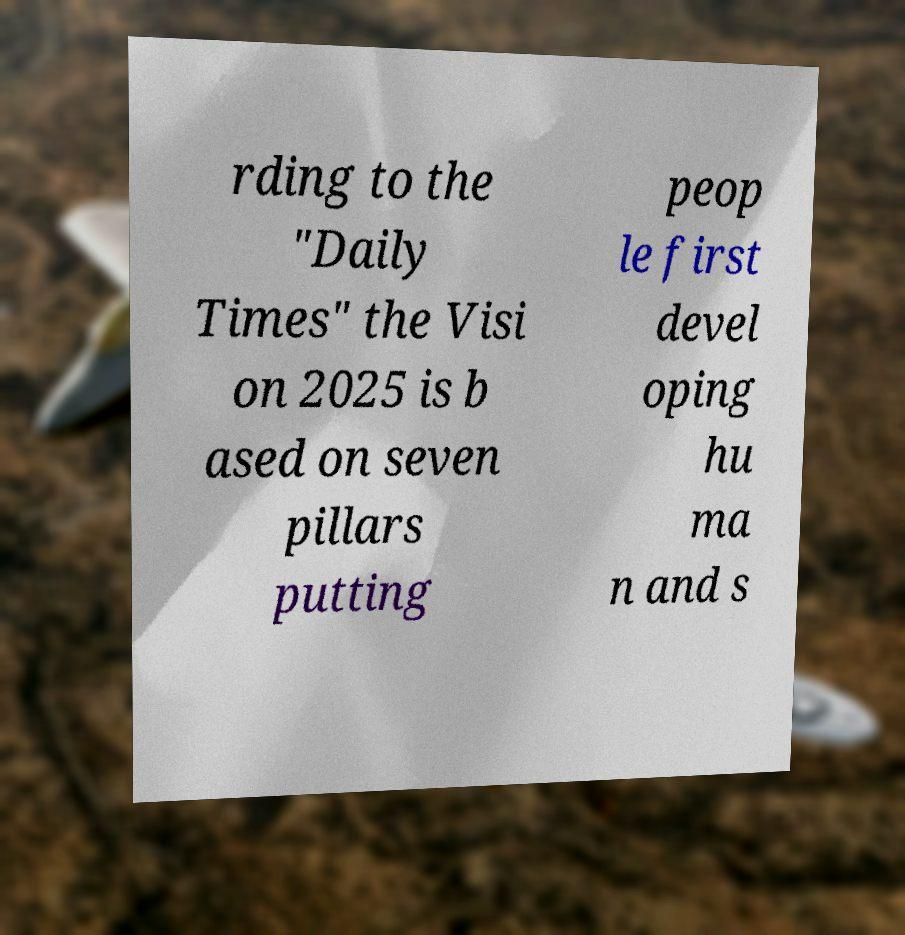What messages or text are displayed in this image? I need them in a readable, typed format. rding to the "Daily Times" the Visi on 2025 is b ased on seven pillars putting peop le first devel oping hu ma n and s 